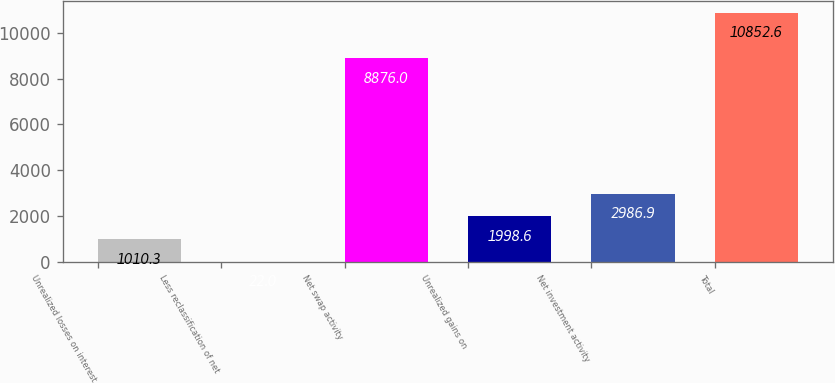Convert chart to OTSL. <chart><loc_0><loc_0><loc_500><loc_500><bar_chart><fcel>Unrealized losses on interest<fcel>Less reclassification of net<fcel>Net swap activity<fcel>Unrealized gains on<fcel>Net investment activity<fcel>Total<nl><fcel>1010.3<fcel>22<fcel>8876<fcel>1998.6<fcel>2986.9<fcel>10852.6<nl></chart> 